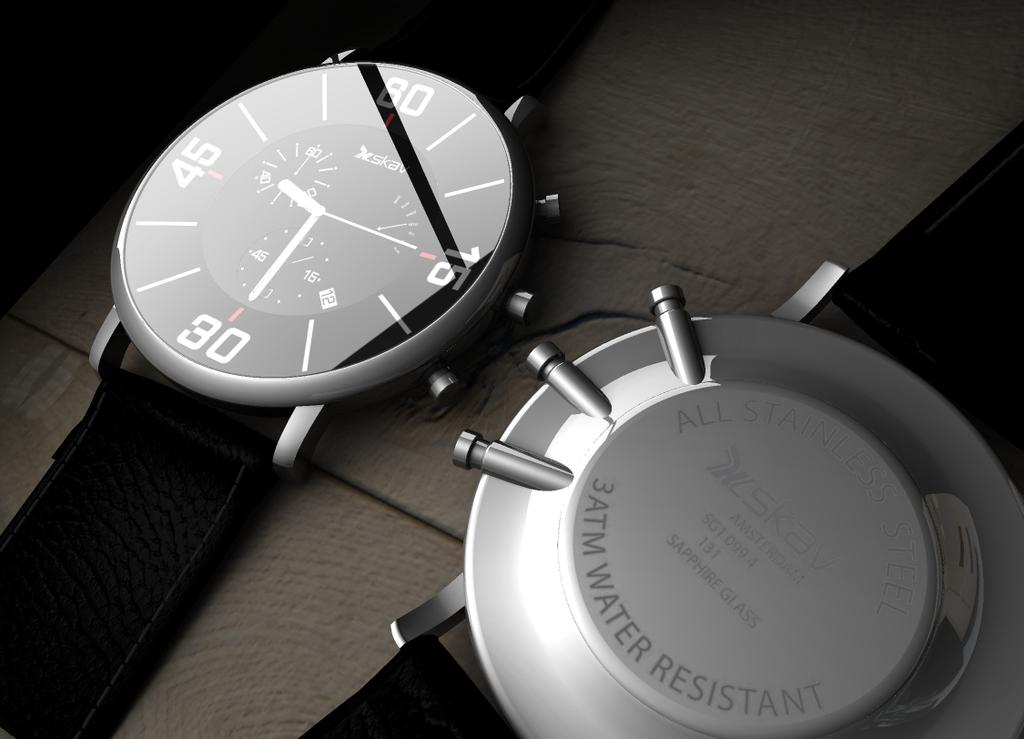<image>
Render a clear and concise summary of the photo. A pair of black wristwatches are on the table with one showing the level of water resistance. 